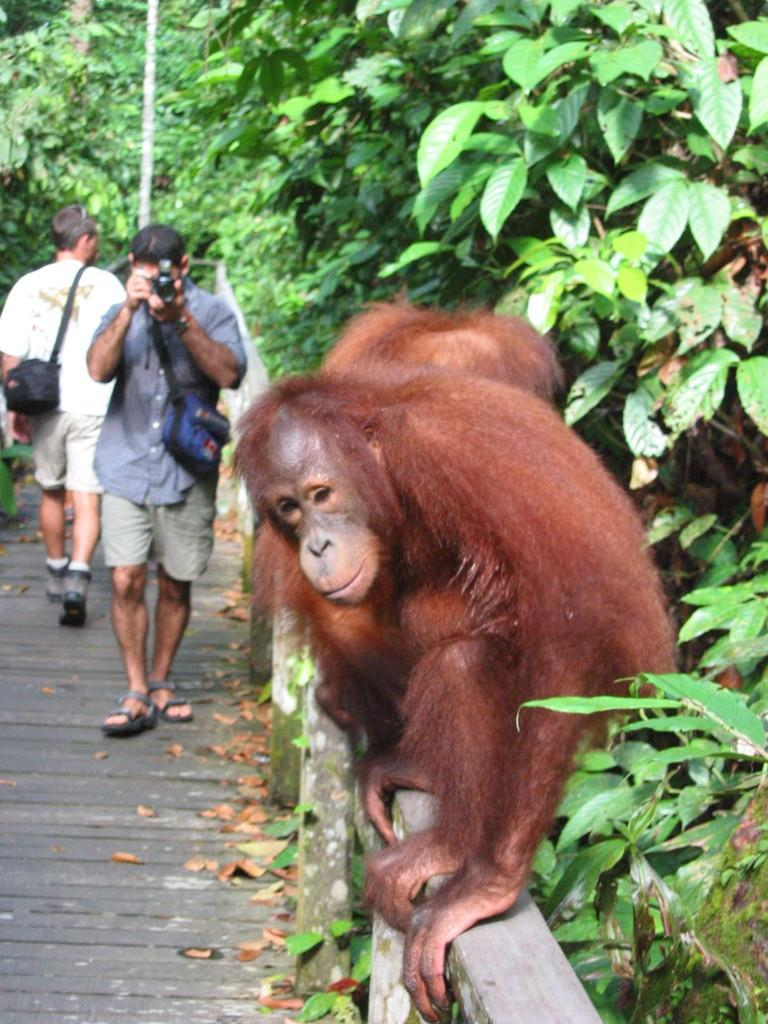What is the monkey doing in the image? The monkey is sitting on a pole in the image. What are the two persons doing in the image? Two persons are walking in the image. What is the person with the camera doing? One person is capturing a picture of the monkey with a camera. What type of vegetation can be seen in the image? There are many trees in the image. What type of smoke can be seen coming from the monkey's tail in the image? There is no smoke present in the image, and the monkey's tail is not mentioned in the provided facts. 